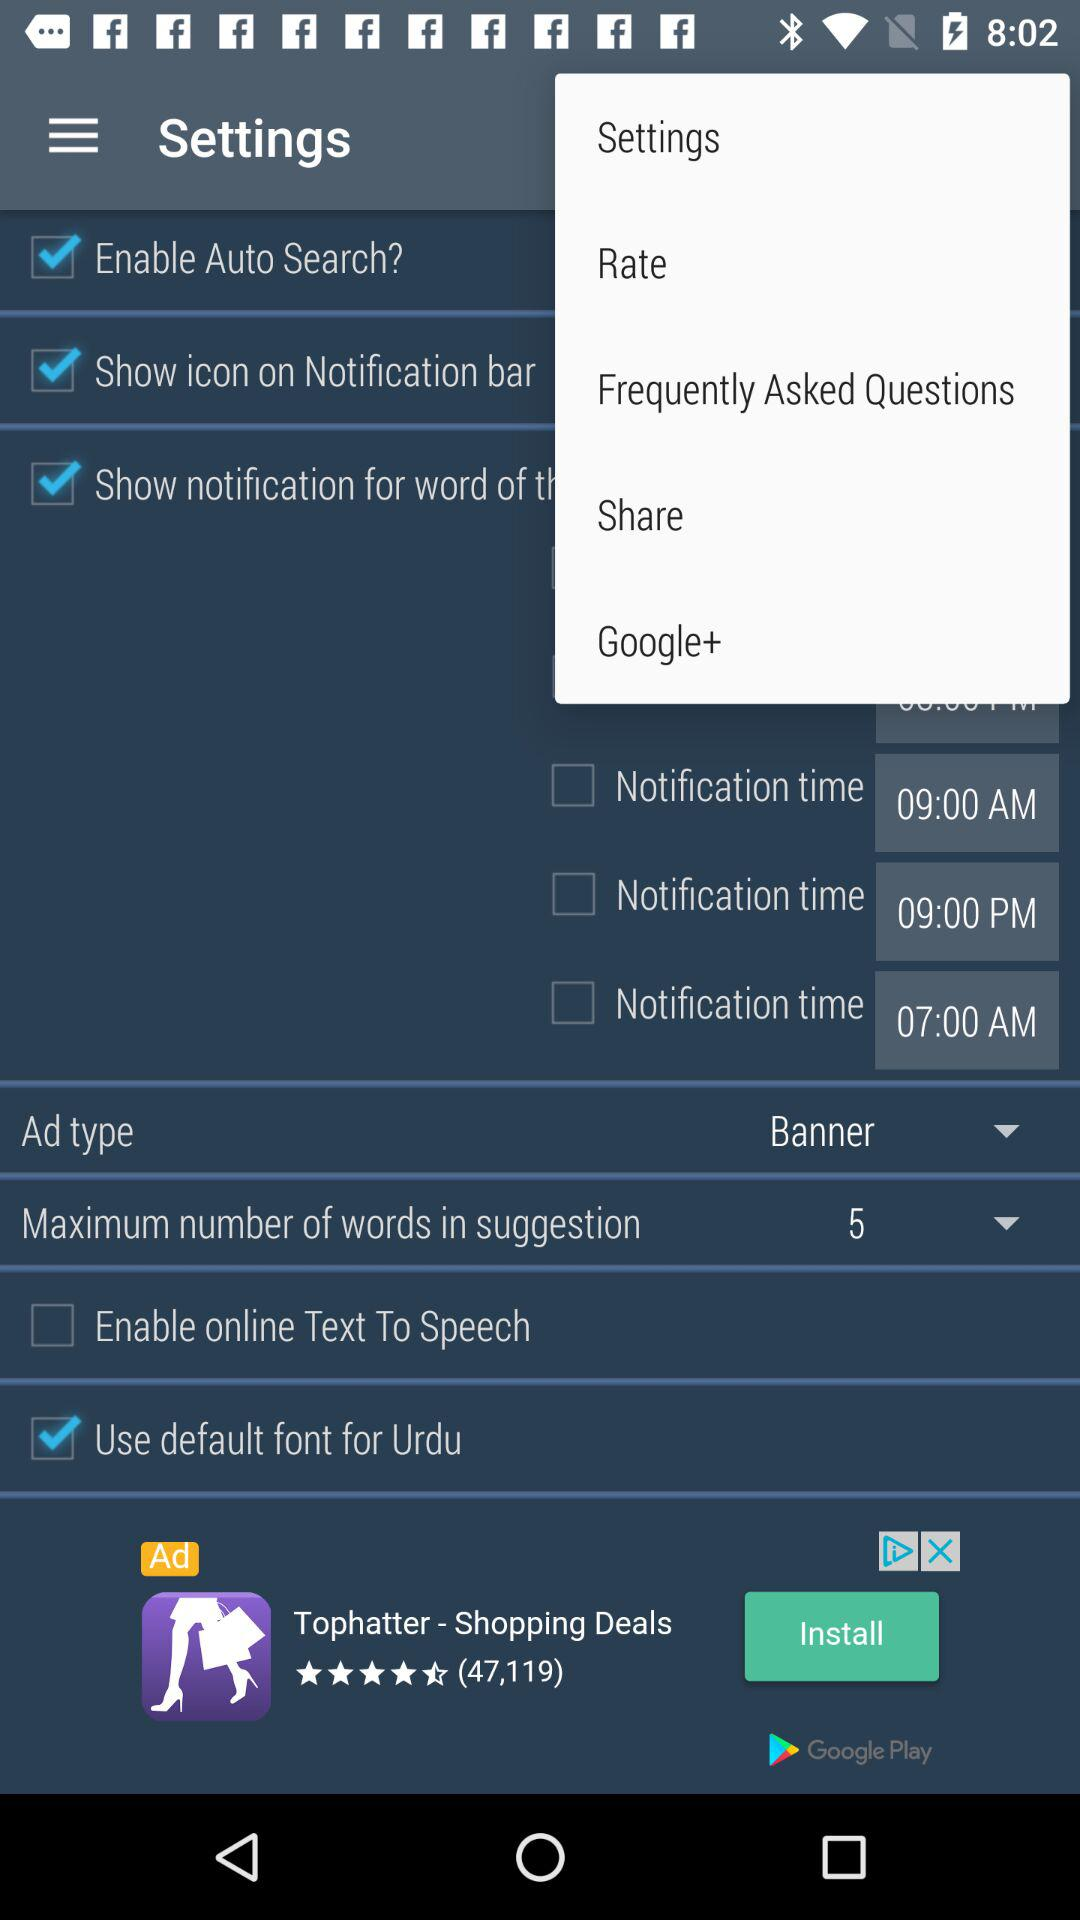What is the given notification time? The given notification times are 09:00 AM, 09:00 PM and 07:00 AM. 